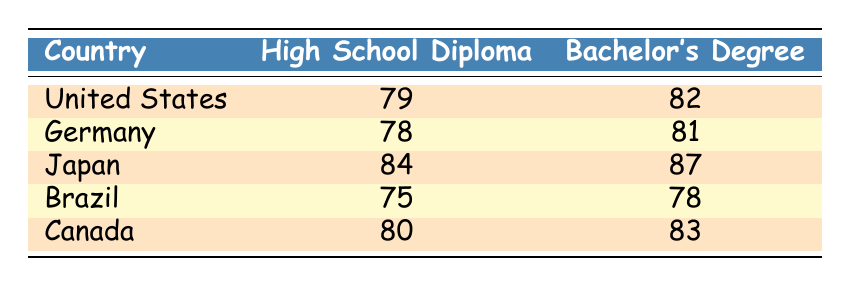What is the life expectancy for individuals with a Bachelor's Degree in Japan? According to the table, Japan has a life expectancy of 87 years for individuals with a Bachelor's Degree, as noted in the corresponding row.
Answer: 87 What is the difference in life expectancy between High School Diploma and Bachelor's Degree holders in the United States? For the United States, the life expectancy for a High School Diploma is 79 years, and for a Bachelor's Degree, it is 82 years. The difference is 82 - 79 = 3 years.
Answer: 3 Which country has the highest life expectancy for individuals with a High School Diploma? By comparing the life expectancies for High School Diploma holders from each country listed, Japan has the highest life expectancy at 84 years.
Answer: 84 Is it true that individuals in Brazil with a Bachelor’s Degree have a higher life expectancy than those with a High School Diploma? In Brazil, the life expectancy for a Bachelor’s Degree is 78 years, and for a High School Diploma, it is 75 years. Since 78 > 75, the statement is true.
Answer: Yes What is the average life expectancy for Bachelor’s Degree holders across all the countries listed? The life expectancies for Bachelor’s Degree holders are 82 (US), 81 (Germany), 87 (Japan), 78 (Brazil), and 83 (Canada). Summing these gives 411 years, and dividing by 5 countries yields an average of 411/5 = 82.2 years.
Answer: 82.2 Which country shows the smallest gap in life expectancy between educational attainment levels? Checking the differences between High School Diploma and Bachelor's Degree holders in each country shows the following: US (3 years), Germany (3 years), Japan (3 years), Brazil (3 years), Canada (3 years). The smallest gap is 3 years, which is the same for all listed countries.
Answer: 3 How does the life expectancy of High School Diploma holders in Canada compare to that in Germany? Canada has a life expectancy of 80 years for High School Diploma holders, whereas Germany has 78 years. Thus, Canadian High School Diploma holders have a higher life expectancy than those in Germany by 2 years.
Answer: 2 What is the combined life expectancy of individuals in Germany for both educational attainment levels? For Germany, the life expectancies are 78 years for a High School Diploma and 81 years for a Bachelor's Degree. Adding these together gives 78 + 81 = 159 years.
Answer: 159 Is it accurate to say that life expectancy increases with educational attainment based on the data provided? By reviewing all the data points, all countries listed demonstrate that life expectancy is higher for those with a Bachelor's Degree compared to those with a High School Diploma. Thus, yes, the statement is accurate.
Answer: Yes 